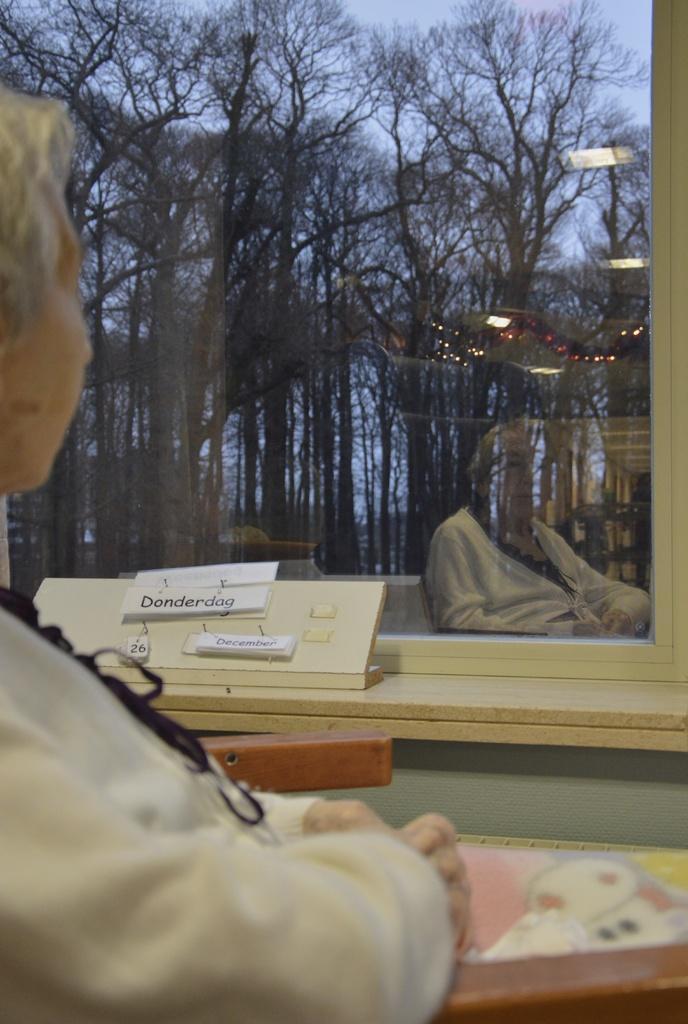Can you describe this image briefly? In the image there is a blond haired woman sitting in front of window and behind it there are trees all over the place and above its sky. 